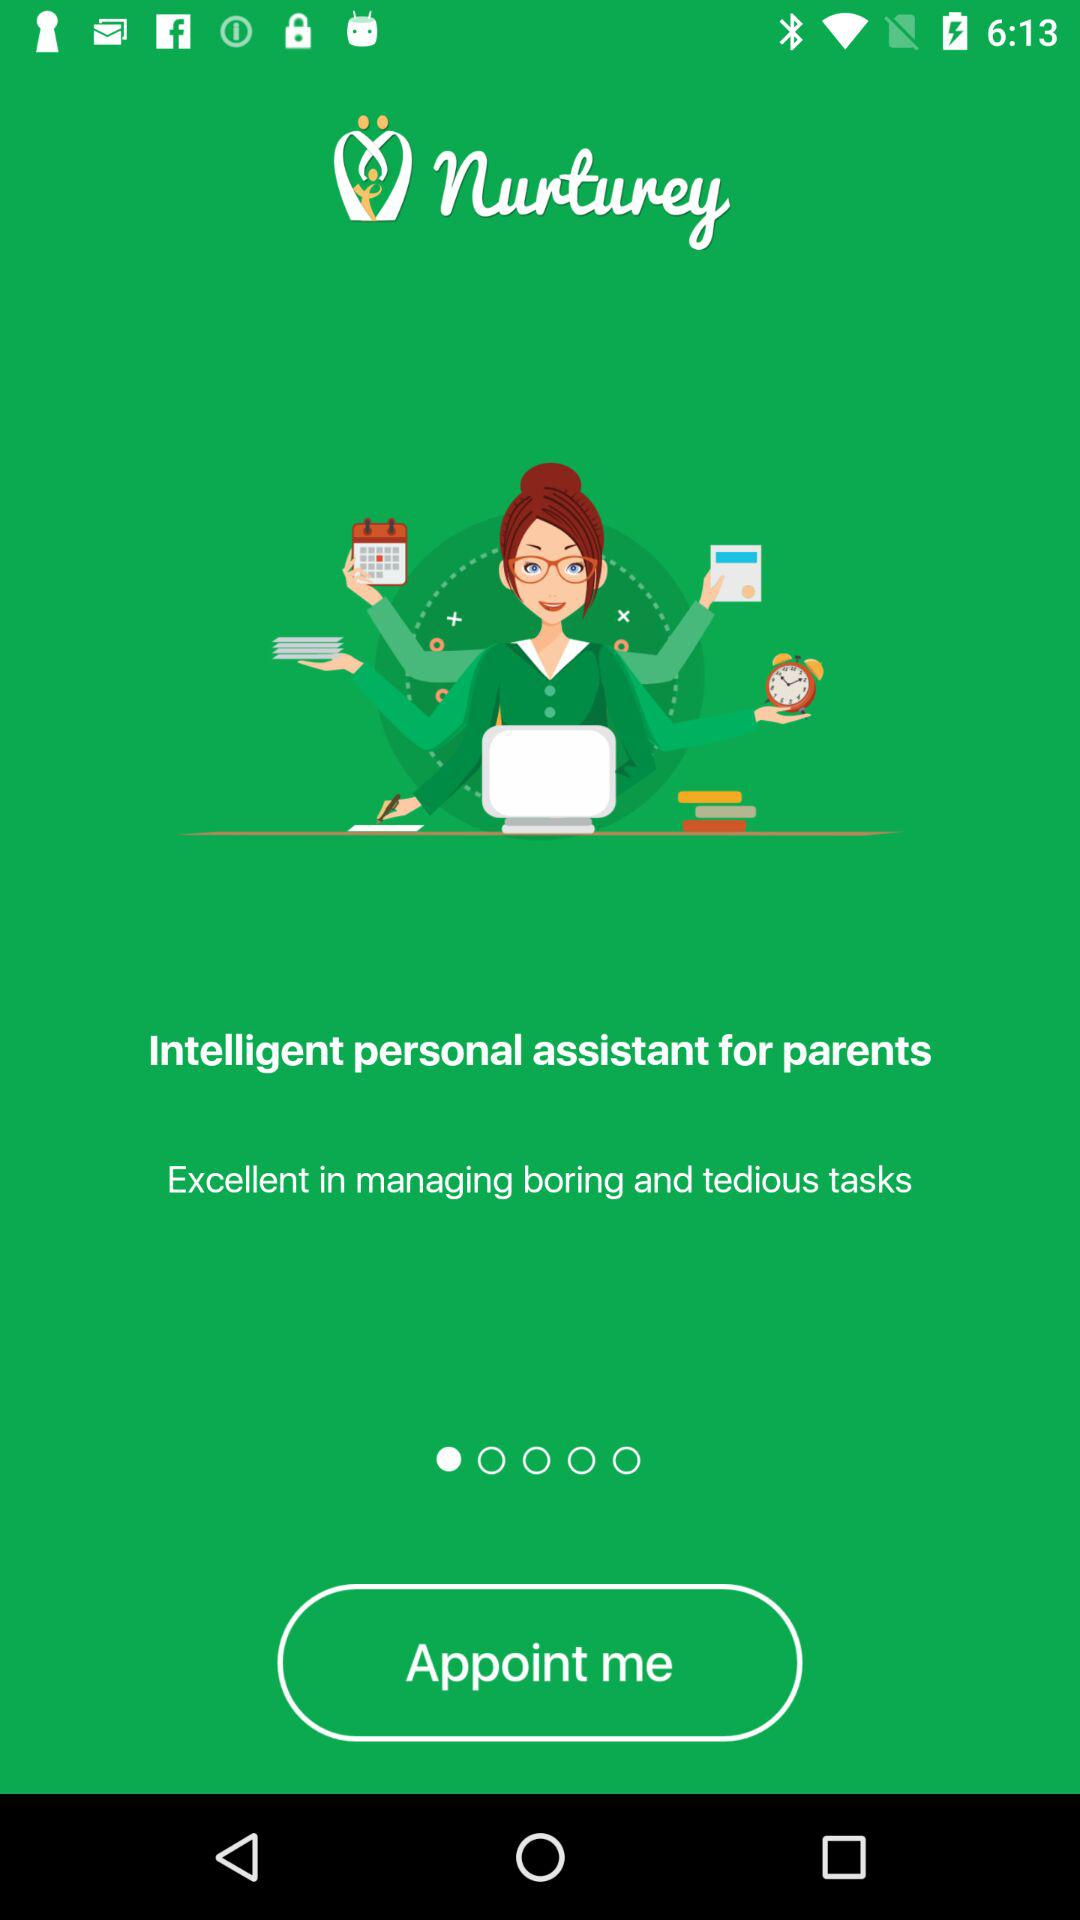What is the application name? The application name is "Nurturey". 